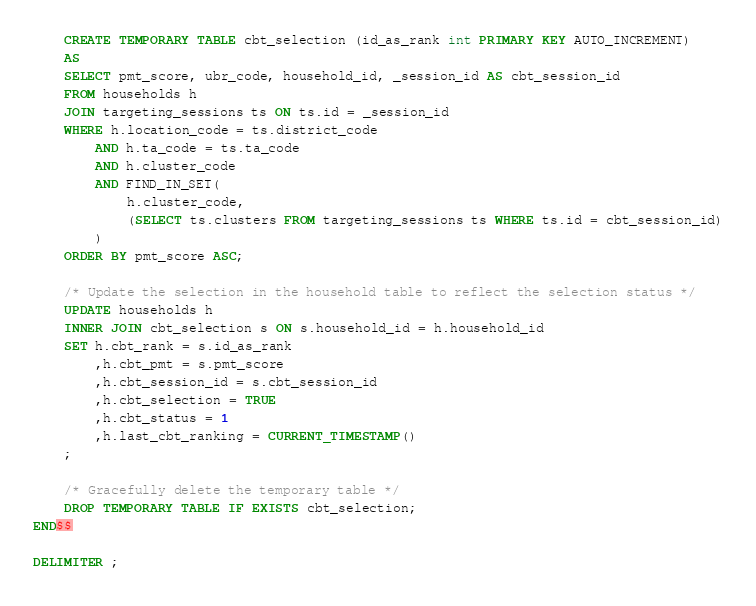Convert code to text. <code><loc_0><loc_0><loc_500><loc_500><_SQL_>	CREATE TEMPORARY TABLE cbt_selection (id_as_rank int PRIMARY KEY AUTO_INCREMENT)
	AS
	SELECT pmt_score, ubr_code, household_id, _session_id AS cbt_session_id
	FROM households h
	JOIN targeting_sessions ts ON ts.id = _session_id
	WHERE h.location_code = ts.district_code
		AND h.ta_code = ts.ta_code
		AND h.cluster_code
		AND FIND_IN_SET(
			h.cluster_code,
			(SELECT ts.clusters FROM targeting_sessions ts WHERE ts.id = cbt_session_id)
		)
	ORDER BY pmt_score ASC;

	/* Update the selection in the household table to reflect the selection status */
	UPDATE households h
	INNER JOIN cbt_selection s ON s.household_id = h.household_id
	SET h.cbt_rank = s.id_as_rank
		,h.cbt_pmt = s.pmt_score
		,h.cbt_session_id = s.cbt_session_id
		,h.cbt_selection = TRUE
		,h.cbt_status = 1
		,h.last_cbt_ranking = CURRENT_TIMESTAMP()
	;

	/* Gracefully delete the temporary table */
	DROP TEMPORARY TABLE IF EXISTS cbt_selection;
END$$

DELIMITER ;</code> 